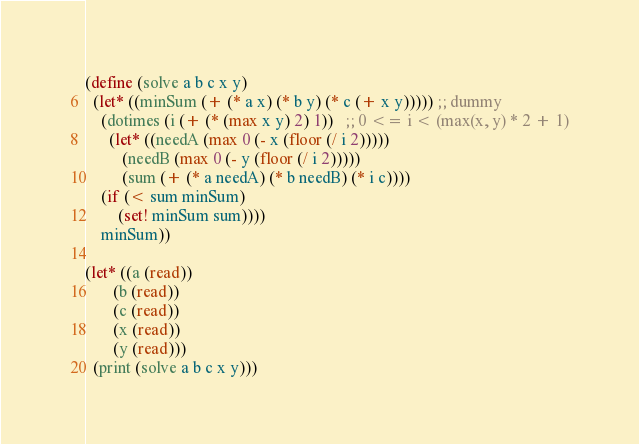<code> <loc_0><loc_0><loc_500><loc_500><_Scheme_>(define (solve a b c x y)
  (let* ((minSum (+ (* a x) (* b y) (* c (+ x y))))) ;; dummy
    (dotimes (i (+ (* (max x y) 2) 1))   ;; 0 <= i < (max(x, y) * 2 + 1)
      (let* ((needA (max 0 (- x (floor (/ i 2)))))
	     (needB (max 0 (- y (floor (/ i 2)))))
	     (sum (+ (* a needA) (* b needB) (* i c))))
	(if (< sum minSum)
	    (set! minSum sum))))
    minSum))

(let* ((a (read))
       (b (read))
       (c (read))
       (x (read))
       (y (read)))
  (print (solve a b c x y)))
</code> 